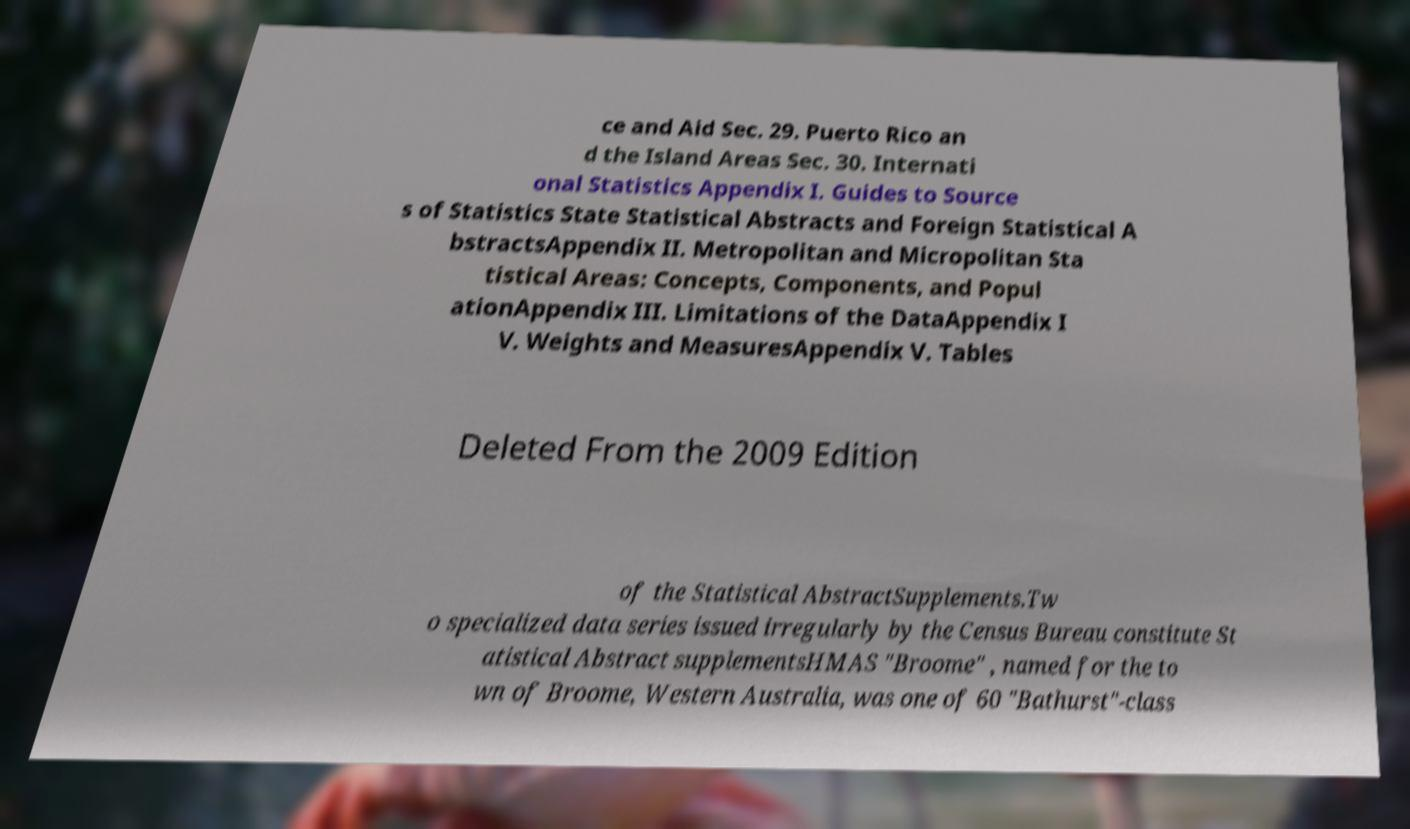Please identify and transcribe the text found in this image. ce and Aid Sec. 29. Puerto Rico an d the Island Areas Sec. 30. Internati onal Statistics Appendix I. Guides to Source s of Statistics State Statistical Abstracts and Foreign Statistical A bstractsAppendix II. Metropolitan and Micropolitan Sta tistical Areas: Concepts, Components, and Popul ationAppendix III. Limitations of the DataAppendix I V. Weights and MeasuresAppendix V. Tables Deleted From the 2009 Edition of the Statistical AbstractSupplements.Tw o specialized data series issued irregularly by the Census Bureau constitute St atistical Abstract supplementsHMAS "Broome" , named for the to wn of Broome, Western Australia, was one of 60 "Bathurst"-class 